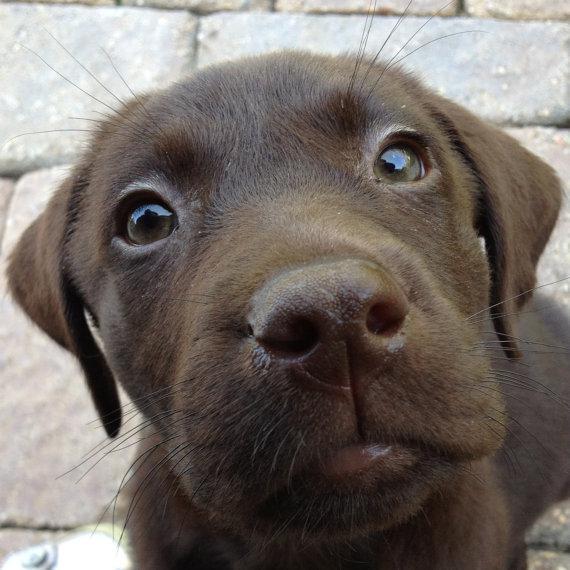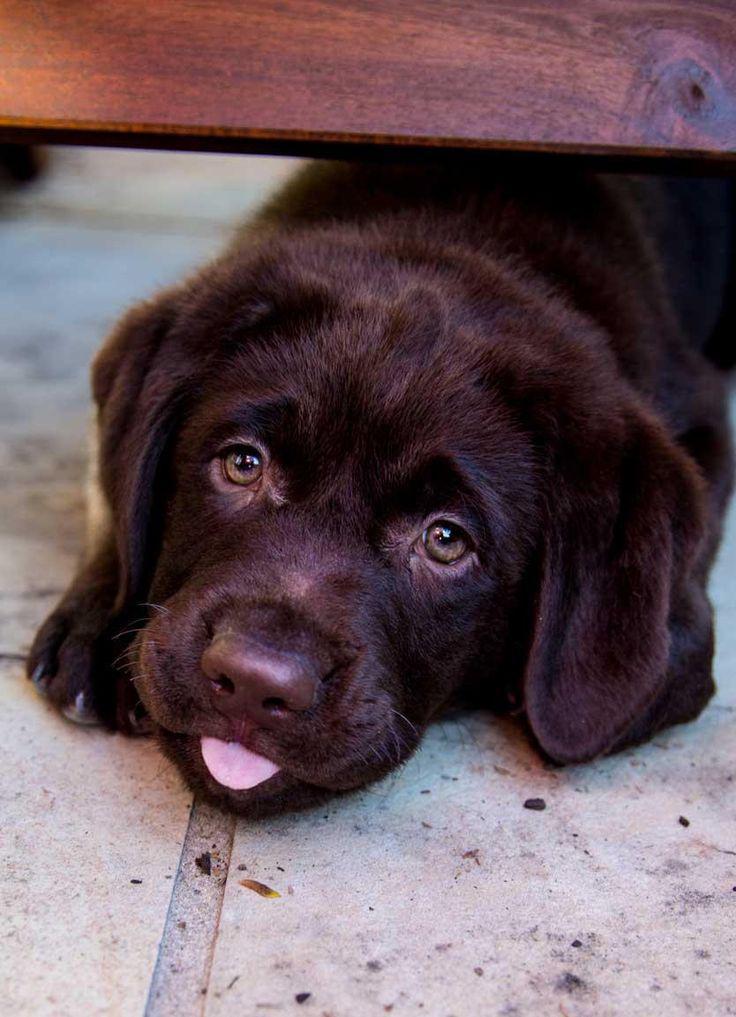The first image is the image on the left, the second image is the image on the right. For the images shown, is this caption "A brown puppy is posed on a printed fabric surface." true? Answer yes or no. No. The first image is the image on the left, the second image is the image on the right. Analyze the images presented: Is the assertion "the animal in the image on the left is in a container" valid? Answer yes or no. No. 